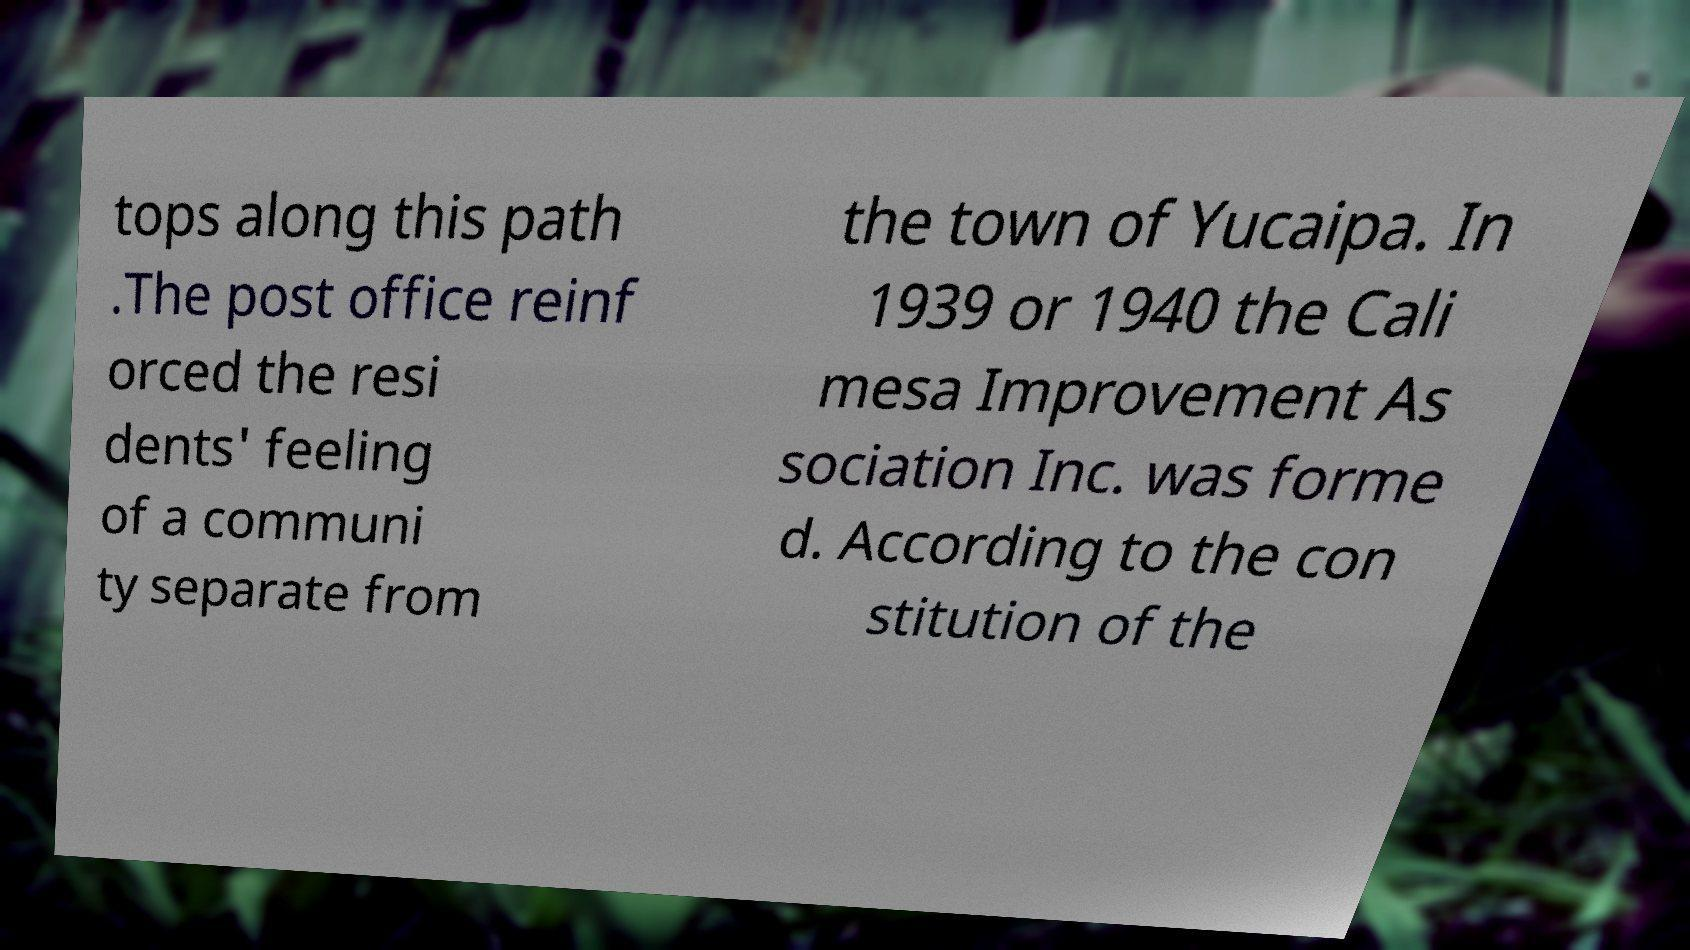Could you assist in decoding the text presented in this image and type it out clearly? tops along this path .The post office reinf orced the resi dents' feeling of a communi ty separate from the town of Yucaipa. In 1939 or 1940 the Cali mesa Improvement As sociation Inc. was forme d. According to the con stitution of the 